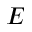<formula> <loc_0><loc_0><loc_500><loc_500>E</formula> 